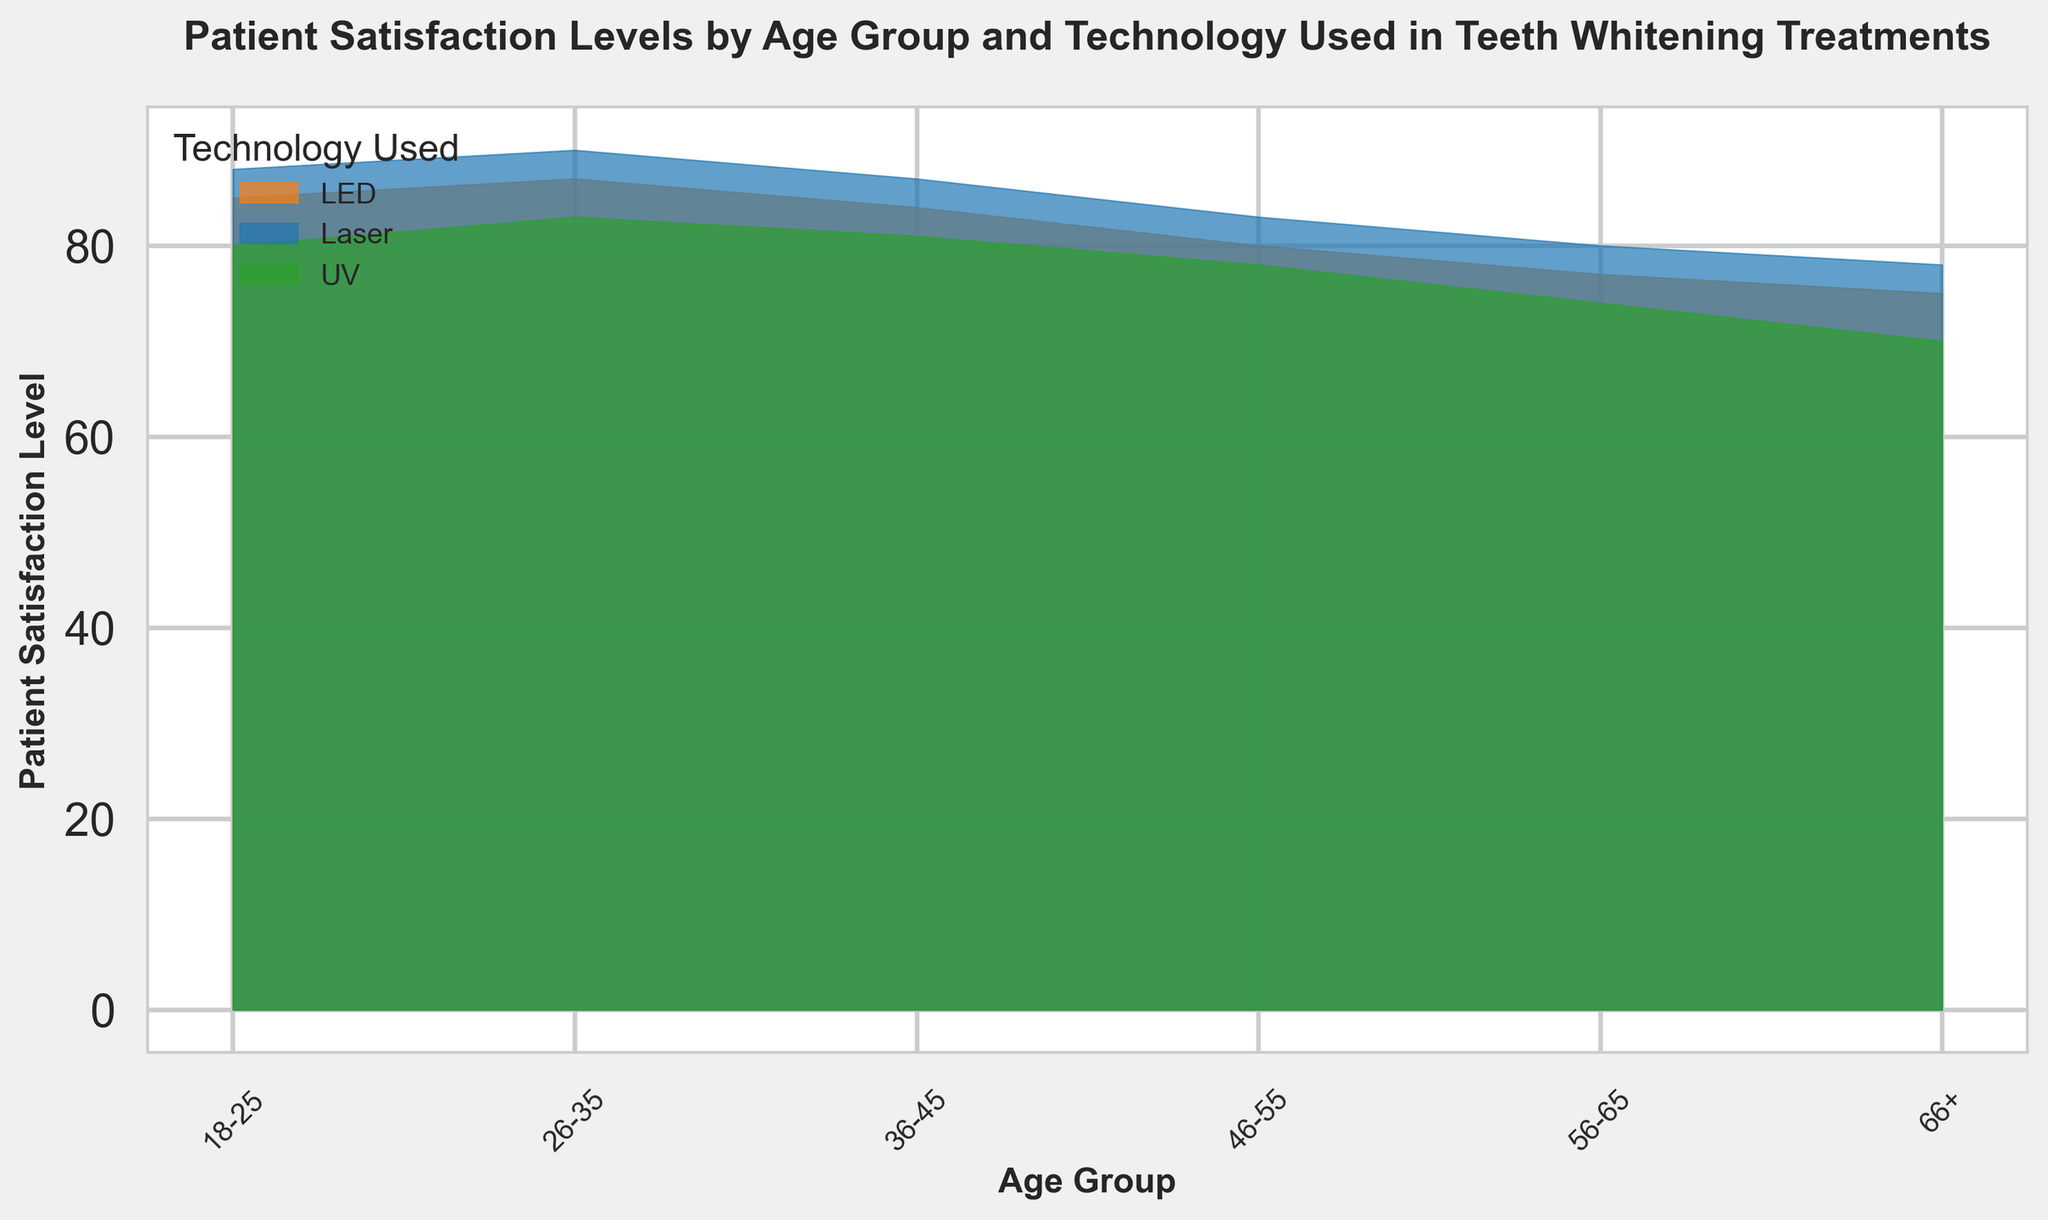What is the highest patient satisfaction level recorded across all age groups and technologies? To find the highest patient satisfaction level recorded, we need to look for the maximum value across all data points in the figure. The highest value shown is 90, which is for the 26-35 age group using the Laser technology.
Answer: 90 Which age group shows the lowest satisfaction level for UV technology? From the figure, the lowest patient satisfaction level for UV technology can be seen in the 66+ age group, indicated by the lowest point of the green area under the '66+' label. The value is 70.
Answer: 66+ Which technology has the most consistent patient satisfaction levels (smallest variation) across age groups? By comparing the width of the areas for each technology across different age groups, the LED technology displays a relatively consistent width across the different age groups, indicating smaller variation in satisfaction levels.
Answer: LED How does the patient satisfaction level of Laser technology for the 56-65 age group compare to that of the same age group using UV technology? For the 56-65 age group, the patient satisfaction level for Laser technology is 80, while for UV technology it is 74. By comparing these numbers, we see that the satisfaction level for Laser is higher.
Answer: Laser has a higher satisfaction level What is the average patient satisfaction level for the LED technology across all age groups? We need to sum up the satisfaction levels for the LED technology across all age groups and divide by the number of age groups: (85+87+84+80+77+75) = 488, and there are 6 age groups. The average is 488/6.
Answer: 81.33 Between which two consecutive age groups does the Laser technology show the largest drop in patient satisfaction levels? Looking at the blue area representing Laser technology, the largest drop in height occurs between the 46-55 and 56-65 age groups, where the satisfaction level drops from 83 to 80.
Answer: 46-55 and 56-65 What is the total increase in patient satisfaction level from 18-25 to 36-45 for UV technology? For UV technology, the patient satisfaction level is 80 for the 18-25 age group and 81 for the 36-45 age group. To find the total increase, we calculate 81 - 80.
Answer: 1 Which technology demonstrates a peak in patient satisfaction levels for the 26-35 age group? The highest peak for the 26-35 age group is seen in the blue area (Laser technology) which reaches a satisfaction level of 90.
Answer: Laser How much higher is the satisfaction level for Laser technology in the 26-35 age group compared to the 46-55 age group? We compare the satisfaction levels for Laser technology: 90 in the 26-35 age group and 83 in the 46-55 age group. The difference is 90 - 83.
Answer: 7 